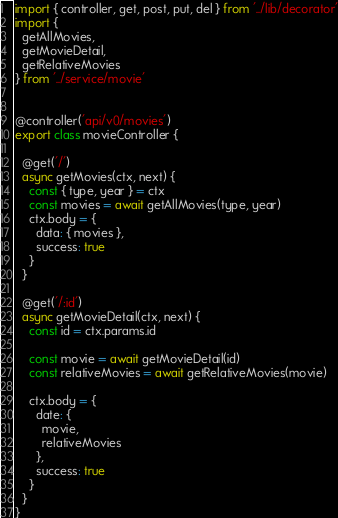Convert code to text. <code><loc_0><loc_0><loc_500><loc_500><_JavaScript_>import { controller, get, post, put, del } from '../lib/decorator'
import {
  getAllMovies,
  getMovieDetail,
  getRelativeMovies
} from '../service/movie'


@controller('api/v0/movies')
export class movieController {

  @get('/')
  async getMovies(ctx, next) {
    const { type, year } = ctx
    const movies = await getAllMovies(type, year)
    ctx.body = {
      data: { movies },
      success: true
    }
  }

  @get('/:id')
  async getMovieDetail(ctx, next) {
    const id = ctx.params.id

    const movie = await getMovieDetail(id)
    const relativeMovies = await getRelativeMovies(movie)

    ctx.body = {
      date: {
        movie,
        relativeMovies
      },
      success: true
    }
  }
}
</code> 